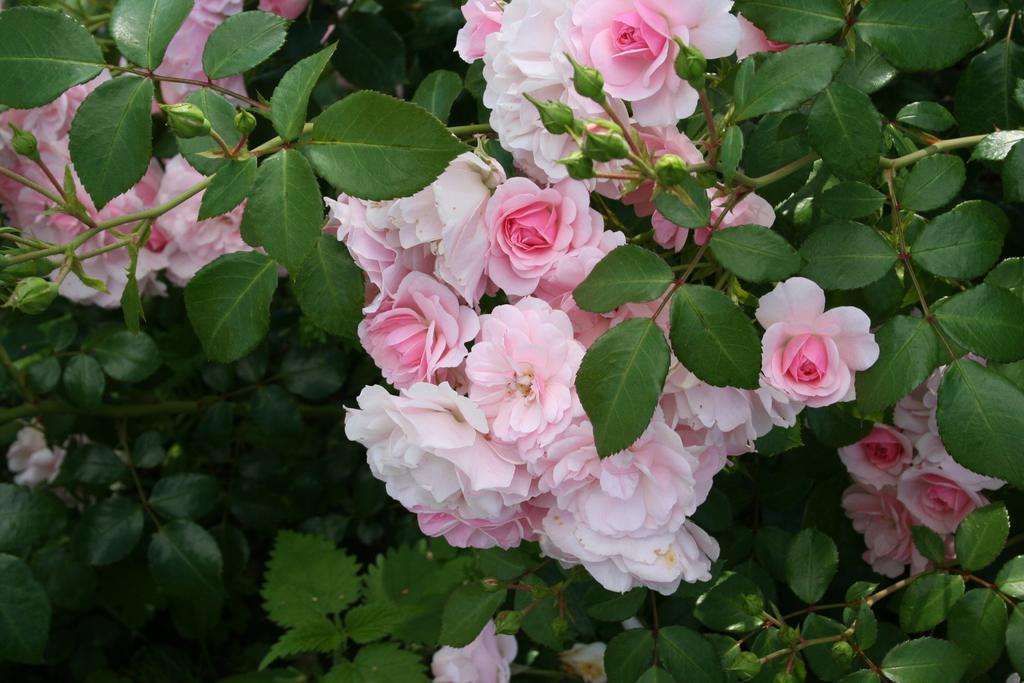Can you describe this image briefly? In this picture we can see few flowers and plants. 